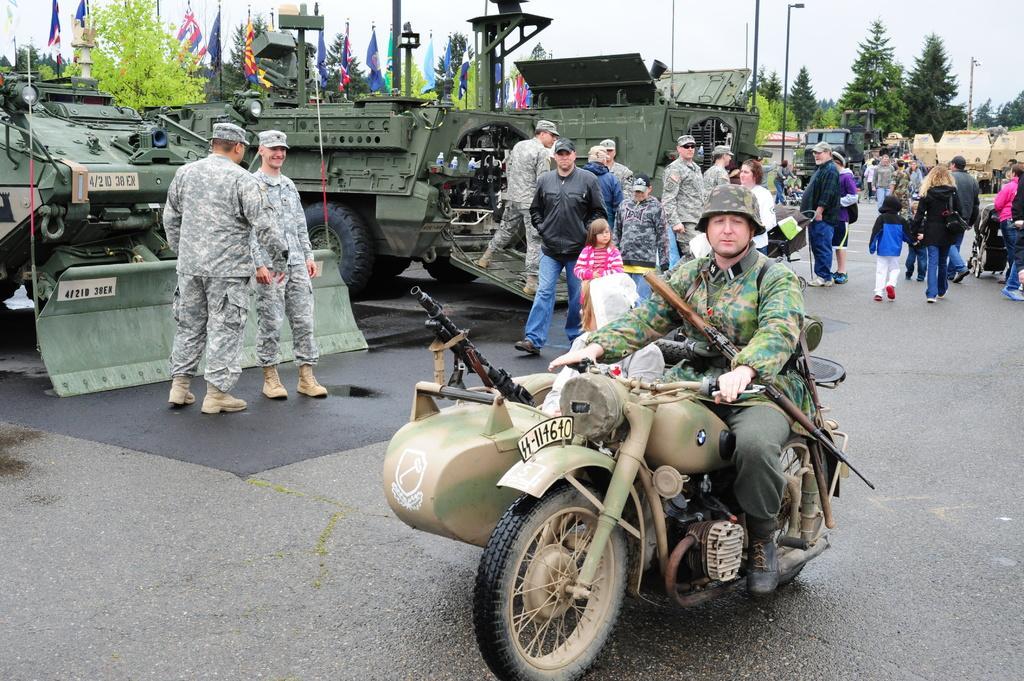Please provide a concise description of this image. In this picture we can see a man wearing a helmet and riding a bike on the road. In the background we can see many people, army tankers, flags, trees and poles on the road. 